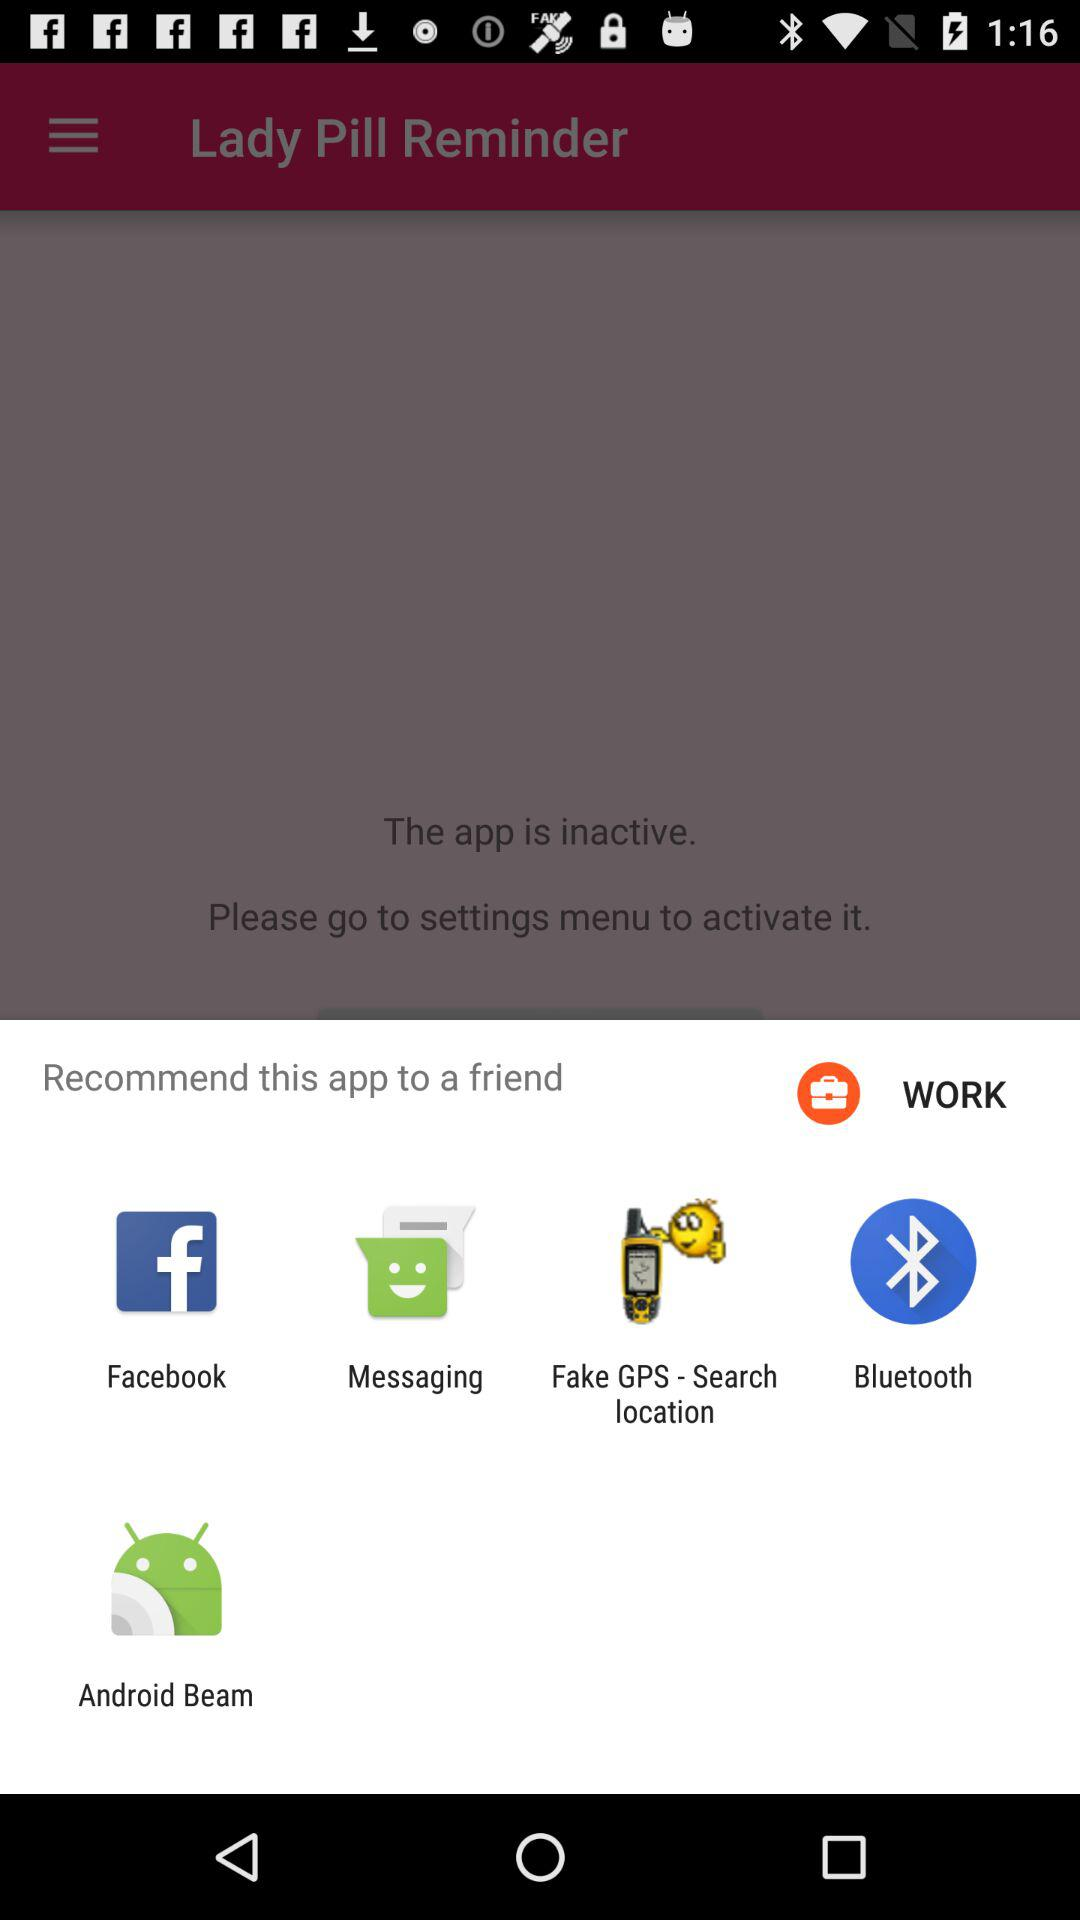What are the options for recommending the "Lady Pill Reminder" app to a friend? The options for recommending the "Lady Pill Reminder" app to a friend are "Facebook", "Messaging", "Fake GPS - Search location", "Bluetooth" and "Android Beam". 